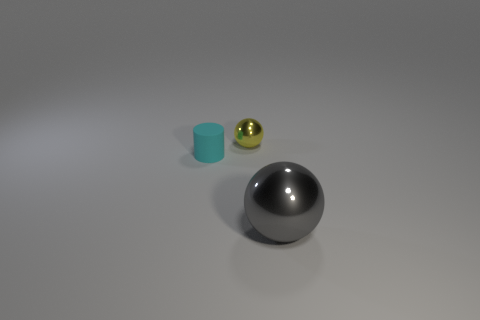There is a ball that is in front of the cyan matte cylinder that is in front of the yellow sphere; what is its size?
Provide a succinct answer. Large. Are there an equal number of tiny cyan rubber things that are behind the big gray metallic object and cyan things behind the small cyan matte thing?
Ensure brevity in your answer.  No. There is another thing that is the same shape as the gray shiny object; what color is it?
Your answer should be compact. Yellow. How many large things have the same color as the tiny shiny sphere?
Keep it short and to the point. 0. There is a object in front of the cyan object; does it have the same shape as the matte object?
Provide a short and direct response. No. The metallic object on the right side of the object behind the thing that is to the left of the tiny yellow shiny ball is what shape?
Provide a short and direct response. Sphere. The matte cylinder is what size?
Your answer should be compact. Small. What color is the other sphere that is the same material as the tiny yellow ball?
Provide a short and direct response. Gray. How many large green spheres have the same material as the big gray sphere?
Give a very brief answer. 0. There is a tiny rubber thing on the left side of the object that is right of the yellow thing; what color is it?
Your answer should be compact. Cyan. 